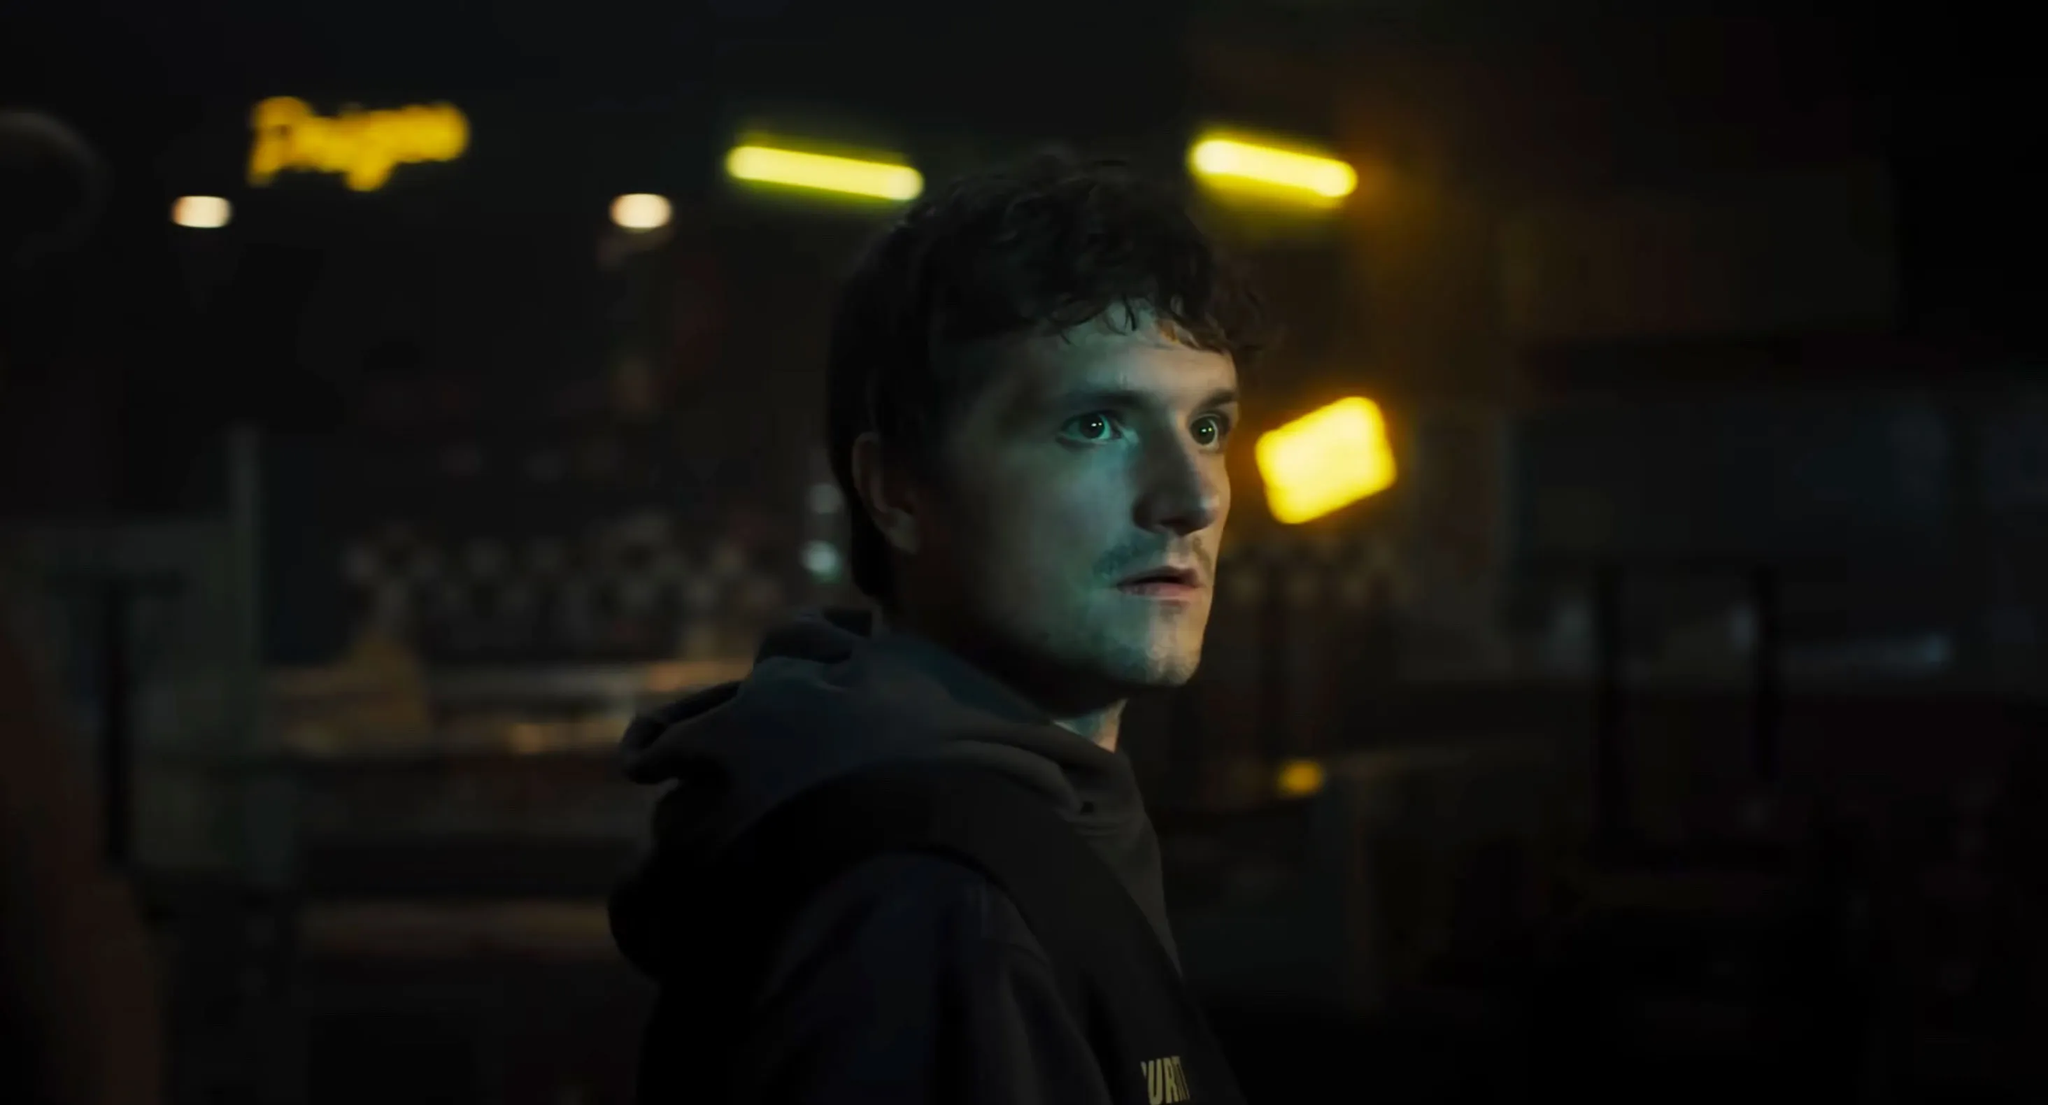Describe the emotions conveyed by the person in this image. The person's expression conveys a sense of deep thought and introspection. The intense gaze and slightly furrowed brow suggest he might be processing something significant or possibly planning his next move. The dim lighting and blurred background elements contribute to a feeling of mystery and seriousness, indicating that he is likely in a contemplative or reflective state of mind. What do you think could be happening in this dimly lit room? Given the atmosphere and the person's demeanor, it could be a scene from a suspenseful or dramatic context like a thriller. Perhaps he is waiting for someone or something important to happen. The nondescript setting with the checkerboard pattern and neon sign suggests it could be a secluded location, possibly a hideout or a place of significant personal meaning to him. Imagine this scene is part of a science fiction movie. Describe the backstory. In a dystopian future, the man is part of a resistance movement fighting against a tyrannical regime. This dimly lit room is a hidden base beneath an abandoned city. The neon signs and checkerboard tiles hint at a once-thriving underground market, now a relic of the past. The man, a former scientist turned rebel, is pondering the next steps in a high-stakes mission to retrieve critical data that could overthrow the oppressors. The soft yellow lights are powered by salvaged technology, symbolizing the last flicker of hope in a dark world. 